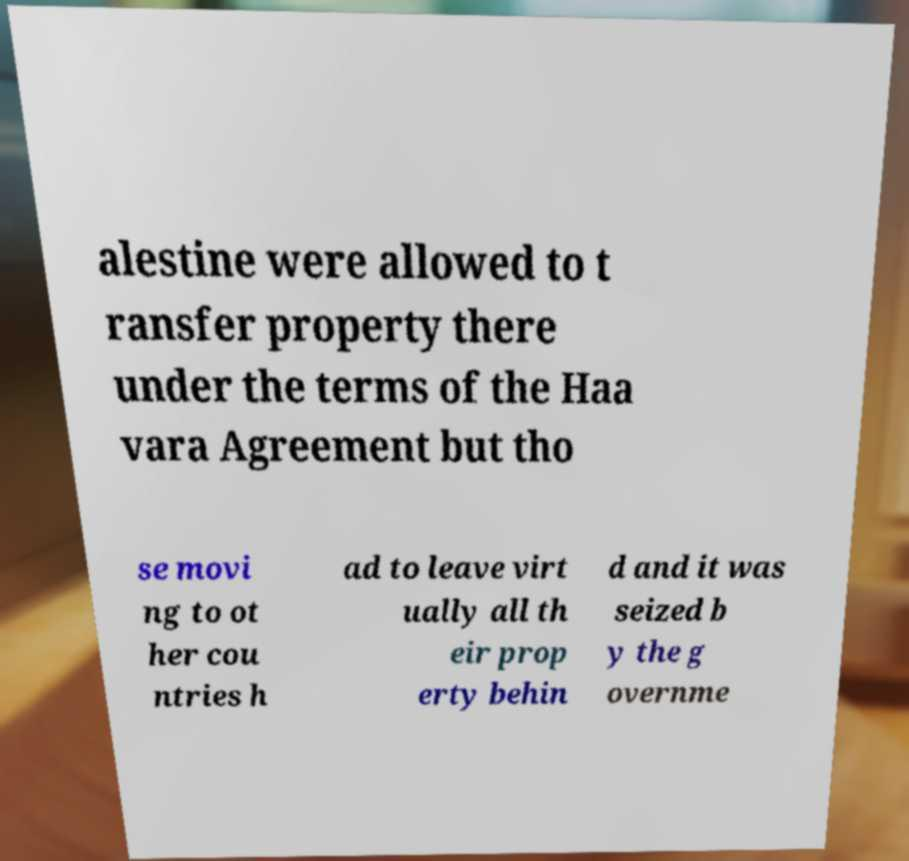Could you extract and type out the text from this image? alestine were allowed to t ransfer property there under the terms of the Haa vara Agreement but tho se movi ng to ot her cou ntries h ad to leave virt ually all th eir prop erty behin d and it was seized b y the g overnme 